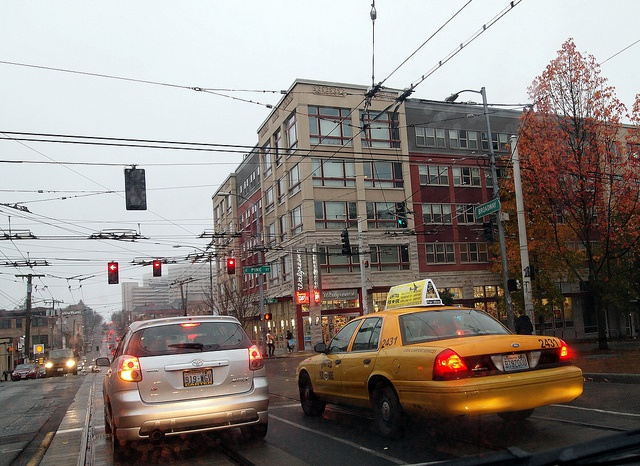Describe the objects in this image and their specific colors. I can see car in white, black, maroon, brown, and gray tones, car in white, gray, darkgray, lightgray, and black tones, car in white, gray, and maroon tones, traffic light in white, gray, and black tones, and car in white, gray, black, darkgray, and maroon tones in this image. 